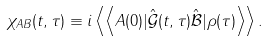<formula> <loc_0><loc_0><loc_500><loc_500>\chi _ { A B } ( t , \tau ) \equiv i \left \langle \left \langle A ( 0 ) | \hat { \mathcal { G } } ( t , \tau ) \hat { \mathcal { B } } | \rho ( \tau ) \right \rangle \right \rangle .</formula> 